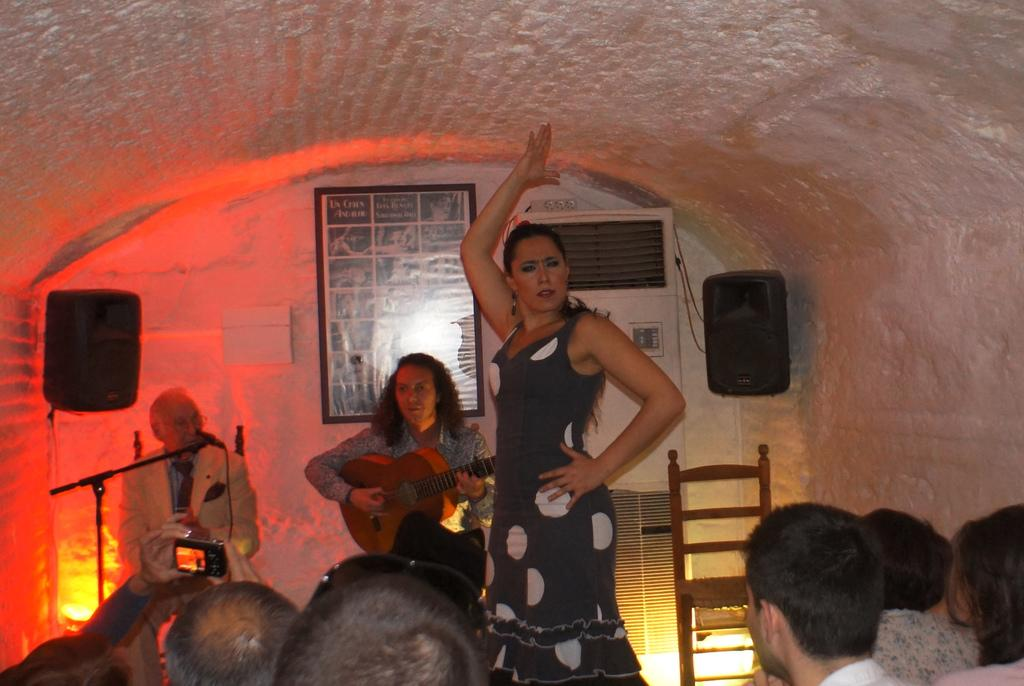What are the two people doing in the image? The two people are playing guitar. What is the woman in the image doing? The woman is dancing. How are the people in the image interacting with the performers? People are looking at the performers. What type of rake is being used to play music in the image? There is no rake present in the image; the two people are playing guitar. Can you tell me how many airports are visible in the image? There are no airports present in the image; it features people playing music and dancing. 